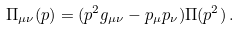<formula> <loc_0><loc_0><loc_500><loc_500>\Pi _ { \mu \nu } ( p ) = ( p ^ { 2 } g _ { \mu \nu } - p _ { \mu } p _ { \nu } ) \Pi ( p ^ { 2 } ) \, .</formula> 